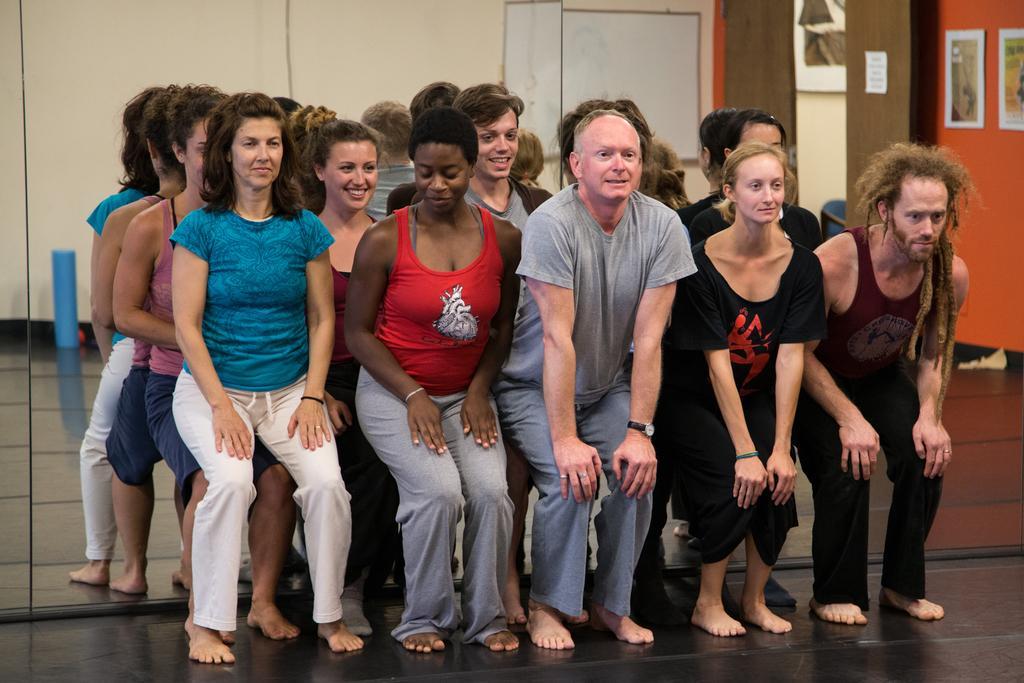Please provide a concise description of this image. In the foreground of this image, there are persons doing wall chair to the mirror and few are sitting on them. In the mirror, we can see the wall and few posters. 